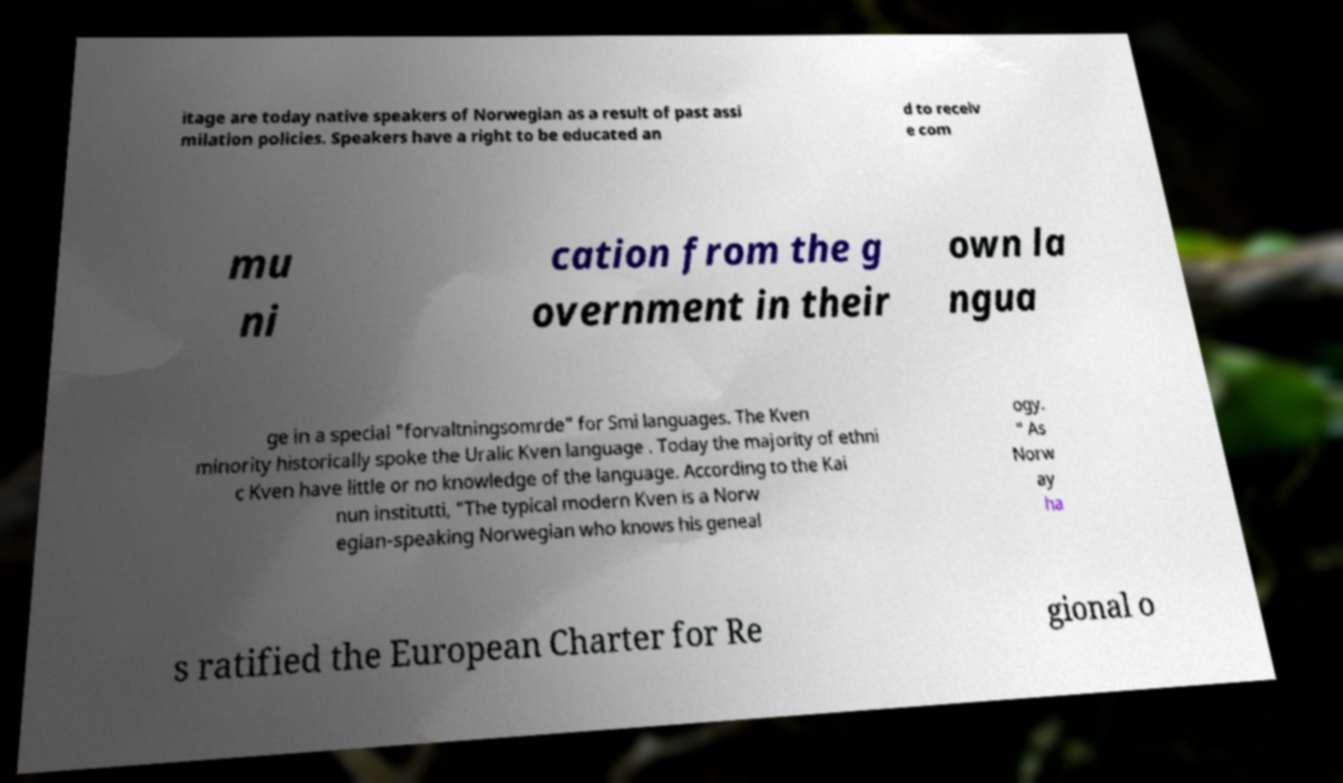There's text embedded in this image that I need extracted. Can you transcribe it verbatim? itage are today native speakers of Norwegian as a result of past assi milation policies. Speakers have a right to be educated an d to receiv e com mu ni cation from the g overnment in their own la ngua ge in a special "forvaltningsomrde" for Smi languages. The Kven minority historically spoke the Uralic Kven language . Today the majority of ethni c Kven have little or no knowledge of the language. According to the Kai nun institutti, "The typical modern Kven is a Norw egian-speaking Norwegian who knows his geneal ogy. " As Norw ay ha s ratified the European Charter for Re gional o 